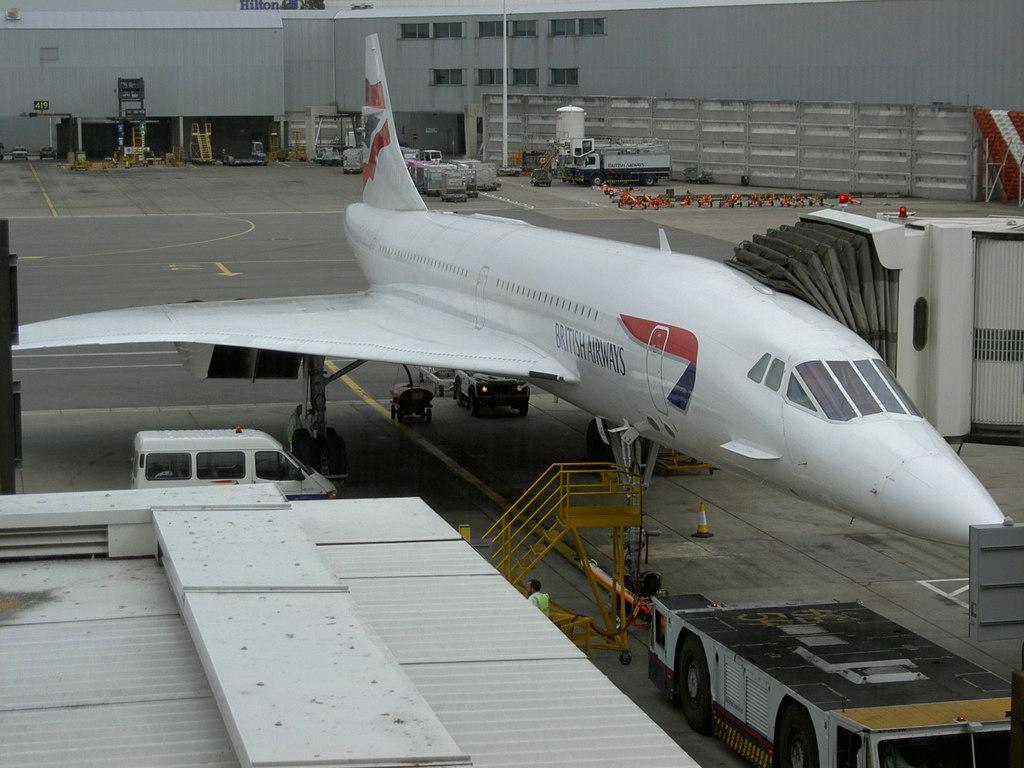Can you describe this image briefly? In this picture there is a view of the airport. In the front there is a white color chartered plane parked on the runway. In the front bottom side we can see the shed roof. Behind we can see airport building, cars and truck on the road. 